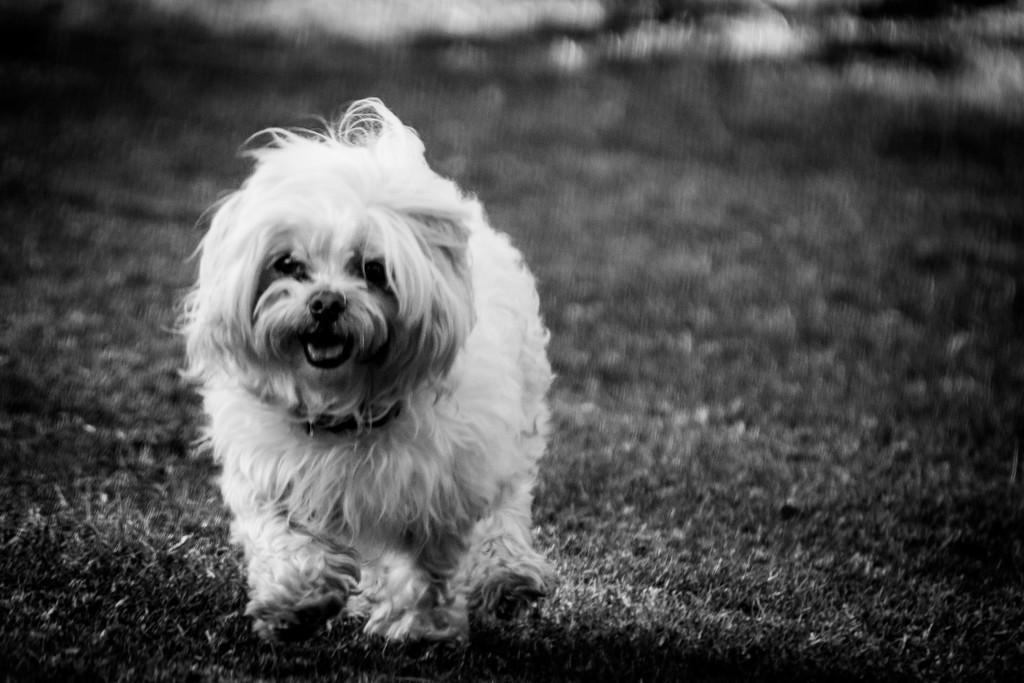Can you describe this image briefly? In this image I can see a dog. I can also see this image is black and white in colour. 